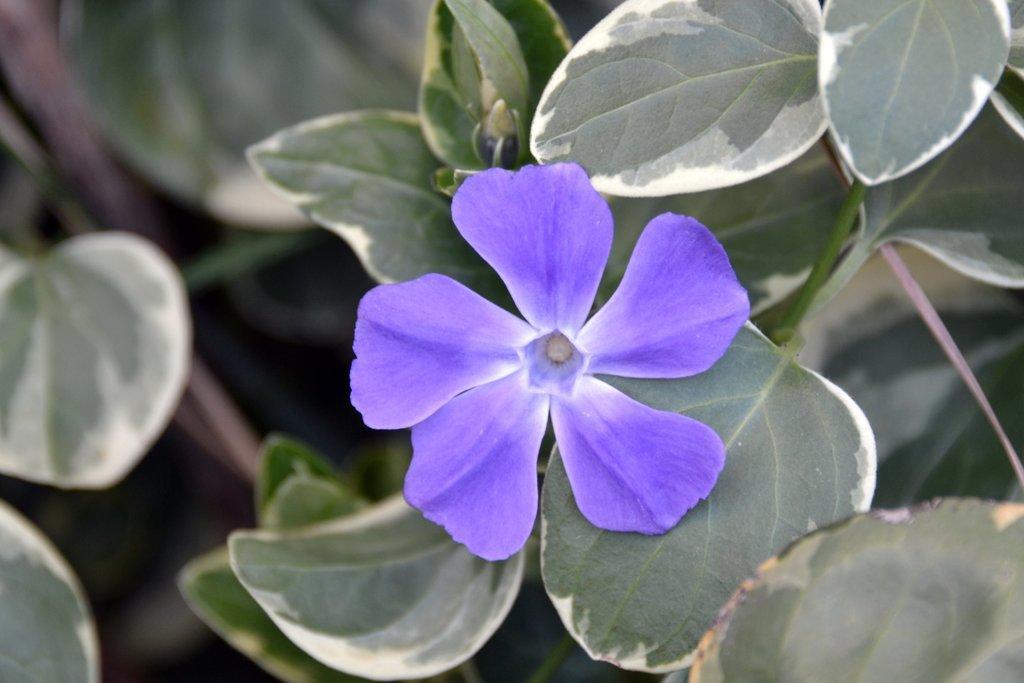Describe this image in one or two sentences. In this picture we can observe a violet color flower to the plant. We can observe some plants and leaves which are in green color. 